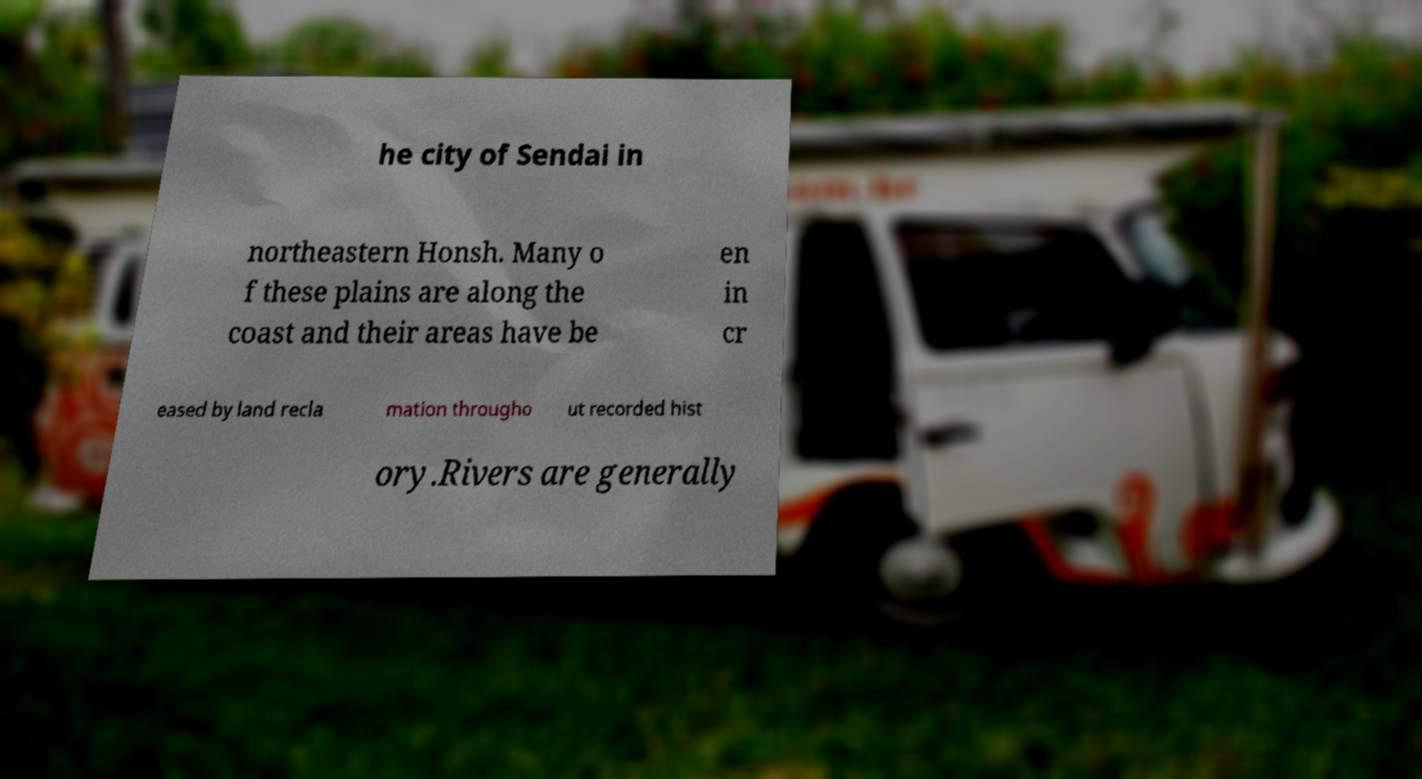Could you extract and type out the text from this image? he city of Sendai in northeastern Honsh. Many o f these plains are along the coast and their areas have be en in cr eased by land recla mation througho ut recorded hist ory.Rivers are generally 